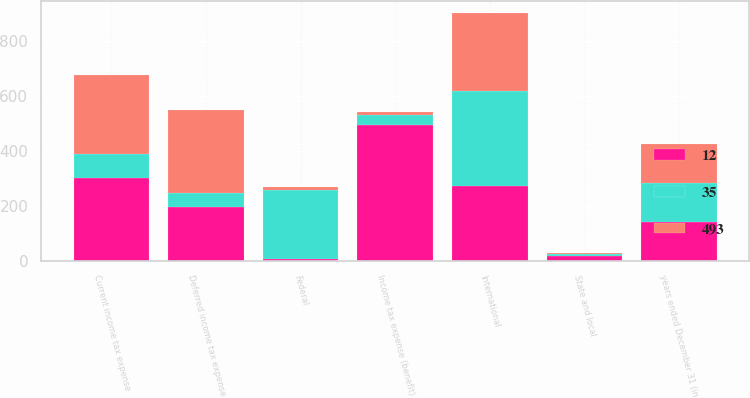<chart> <loc_0><loc_0><loc_500><loc_500><stacked_bar_chart><ecel><fcel>years ended December 31 (in<fcel>Federal<fcel>State and local<fcel>International<fcel>Current income tax expense<fcel>Deferred income tax expense<fcel>Income tax expense (benefit)<nl><fcel>12<fcel>141<fcel>8<fcel>18<fcel>273<fcel>299<fcel>194<fcel>493<nl><fcel>493<fcel>141<fcel>10<fcel>3<fcel>282<fcel>289<fcel>301<fcel>12<nl><fcel>35<fcel>141<fcel>251<fcel>6<fcel>345<fcel>88<fcel>53<fcel>35<nl></chart> 